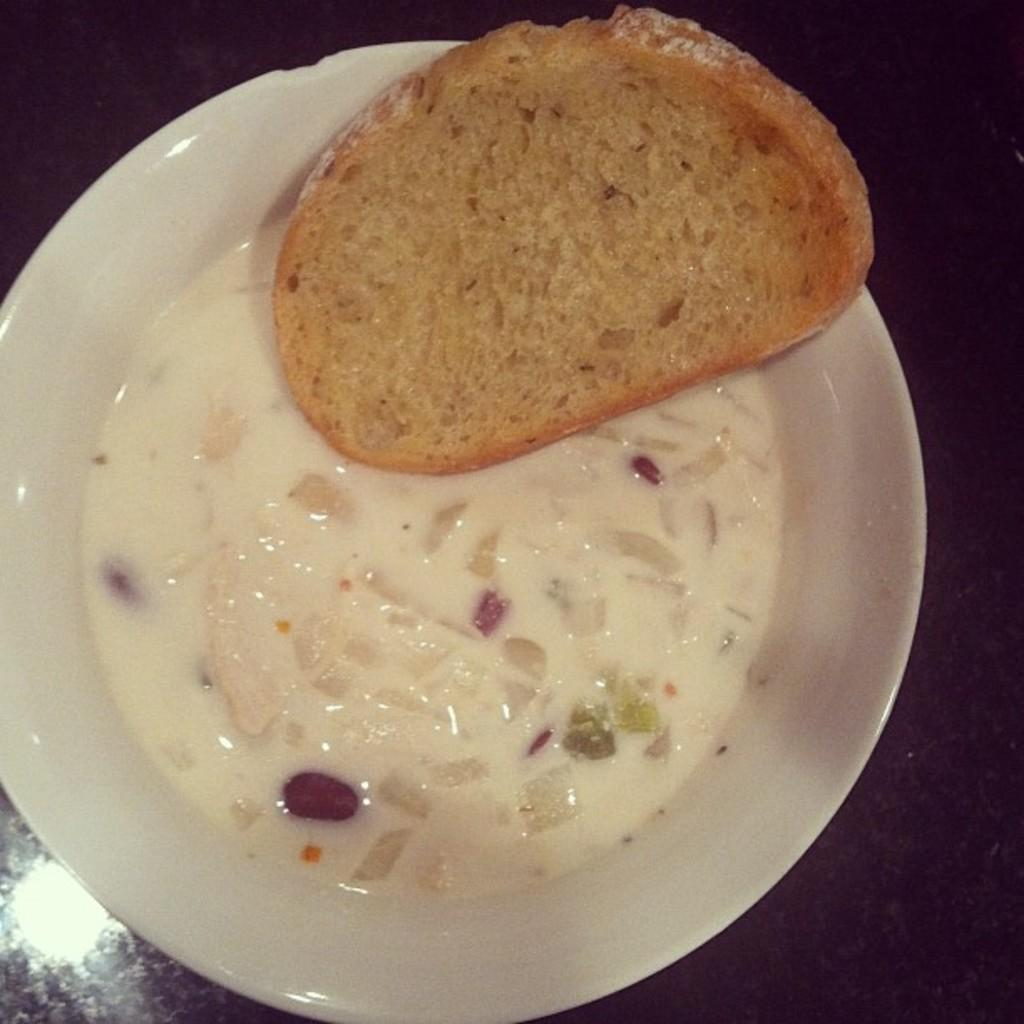What is on the plate in the image? There is food on the plate in the image. Can you describe the color of the plate? The plate in the image is white. What type of food can be seen on the plate? There is a brown-colored bread on the plate. What type of bears can be seen playing in the shade in the image? There are no bears present in the image; it only features a white plate with food on it. 